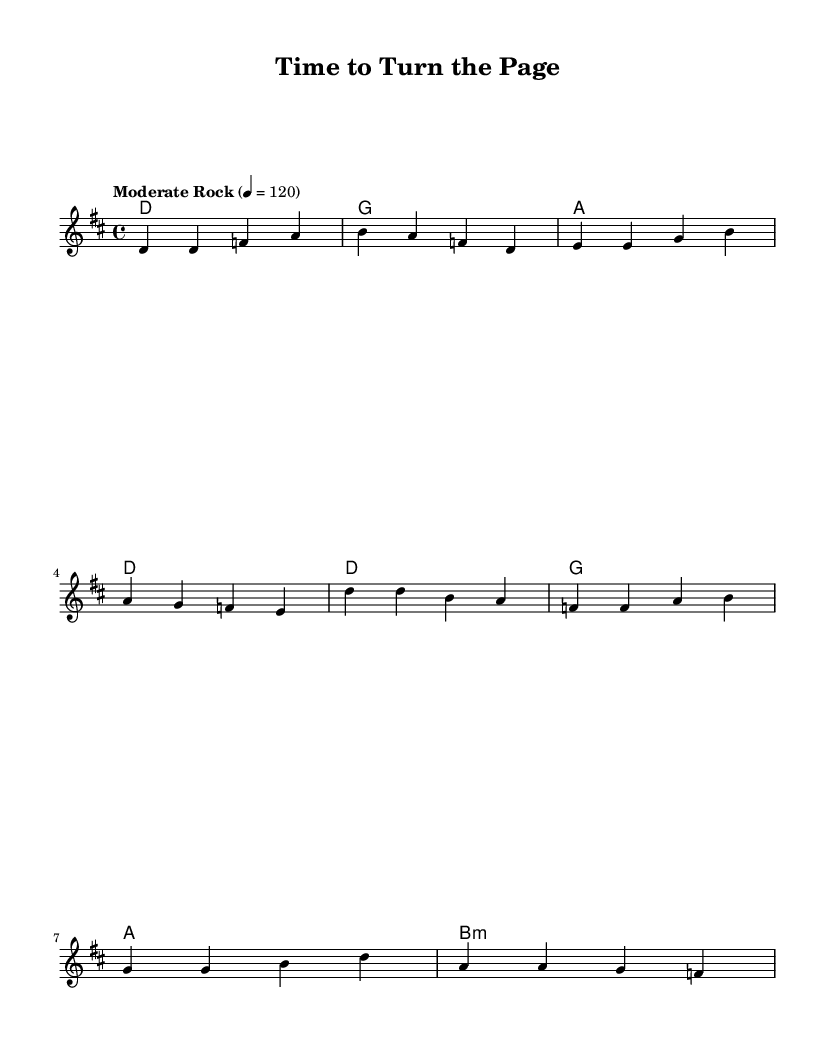What is the key signature of this music? The key signature is D major, which has two sharps (F# and C#).
Answer: D major What is the time signature of this music? The time signature is 4/4, indicating four beats per measure.
Answer: 4/4 What is the tempo marking of this piece? The tempo marking is "Moderate Rock", with a tempo of 120 beats per minute.
Answer: Moderate Rock What are the first three notes of the verse? The first three notes of the verse are D, D, F, as indicated in the melody line.
Answer: D, D, F How many measures does the chorus contain? The chorus contains four measures, as shown by the grouped notes and bars in the melody.
Answer: Four What is the last note of the melody? The last note of the melody from the provided music is E, from the last measure of the verse.
Answer: E What does the lyric "It's time to turn the page" signify in the context of the song? This lyric signifies a moment of personal growth and change, suggesting moving forward and embracing new experiences, which aligns with the song's theme.
Answer: Personal growth 